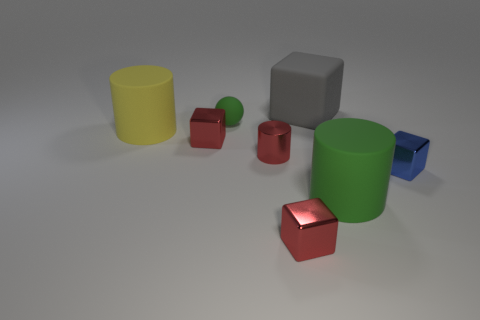Subtract all yellow balls. How many red cubes are left? 2 Subtract all large rubber cylinders. How many cylinders are left? 1 Subtract 1 cylinders. How many cylinders are left? 2 Subtract all gray cubes. How many cubes are left? 3 Subtract all yellow cubes. Subtract all green spheres. How many cubes are left? 4 Add 2 small purple balls. How many objects exist? 10 Subtract all cylinders. How many objects are left? 5 Add 6 cubes. How many cubes are left? 10 Add 3 big green objects. How many big green objects exist? 4 Subtract 0 cyan cubes. How many objects are left? 8 